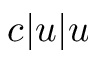Convert formula to latex. <formula><loc_0><loc_0><loc_500><loc_500>c | u | u</formula> 